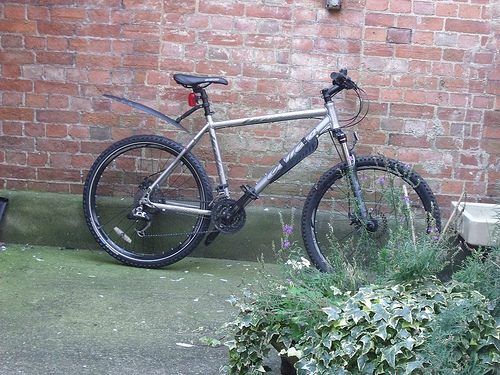<image>
Can you confirm if the wheel is to the left of the steer? Yes. From this viewpoint, the wheel is positioned to the left side relative to the steer. Where is the cycle in relation to the wall? Is it behind the wall? Yes. From this viewpoint, the cycle is positioned behind the wall, with the wall partially or fully occluding the cycle. Is the cycle in the wall? No. The cycle is not contained within the wall. These objects have a different spatial relationship. 